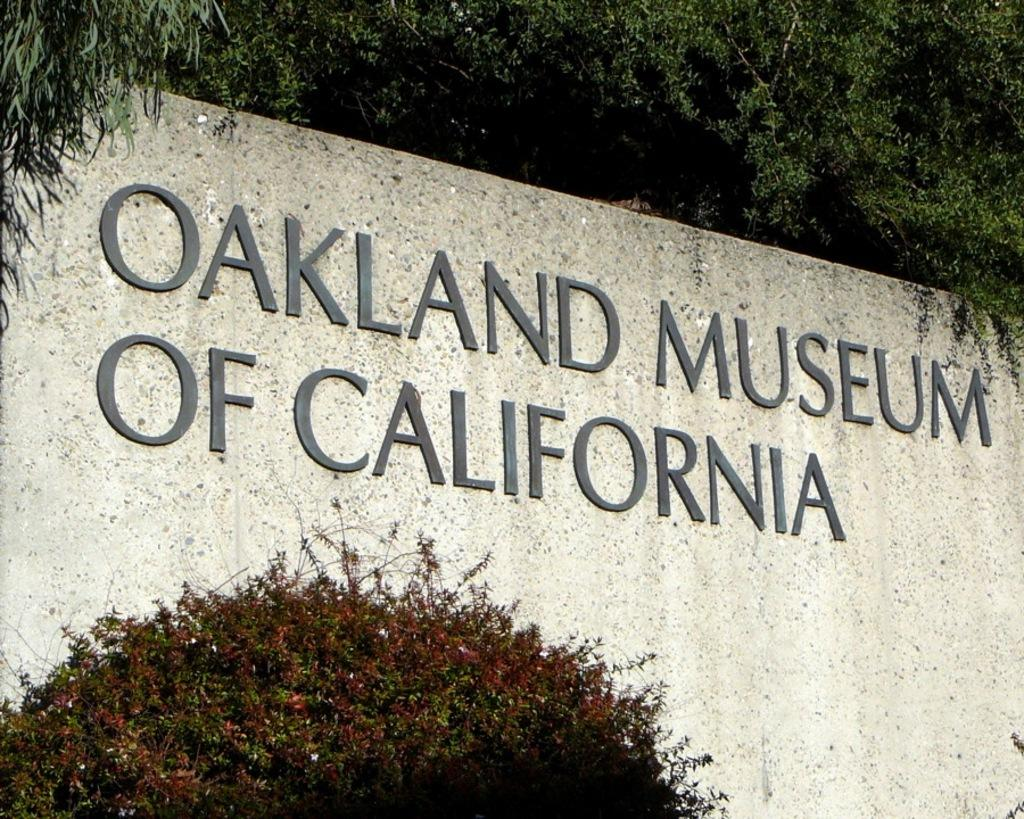What type of vegetation is present at the bottom of the image? There are plants at the bottom of the image. What can be found in the middle of the image? There is text on a stone in the middle of the image. What is visible at the top of the image? There is greenery at the top of the image. What event is being offered by the dad in the image? There is no event or dad present in the image; it features plants, text on a stone, and greenery. 